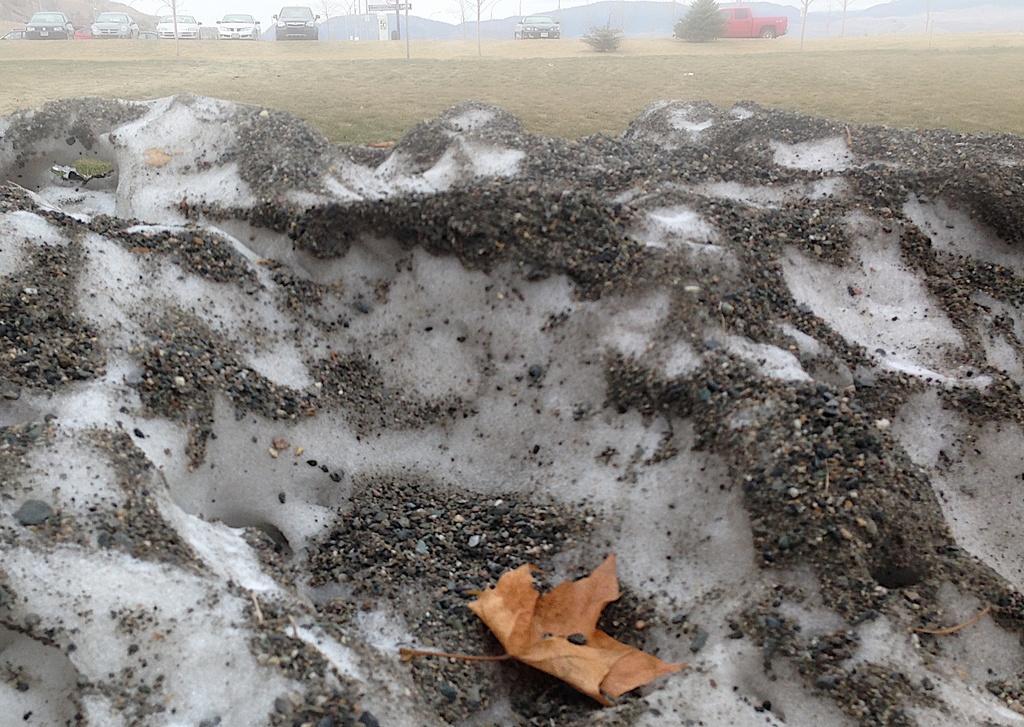Could you give a brief overview of what you see in this image? In this image, we can see sand, there is grass on the ground, we can see some cars. 